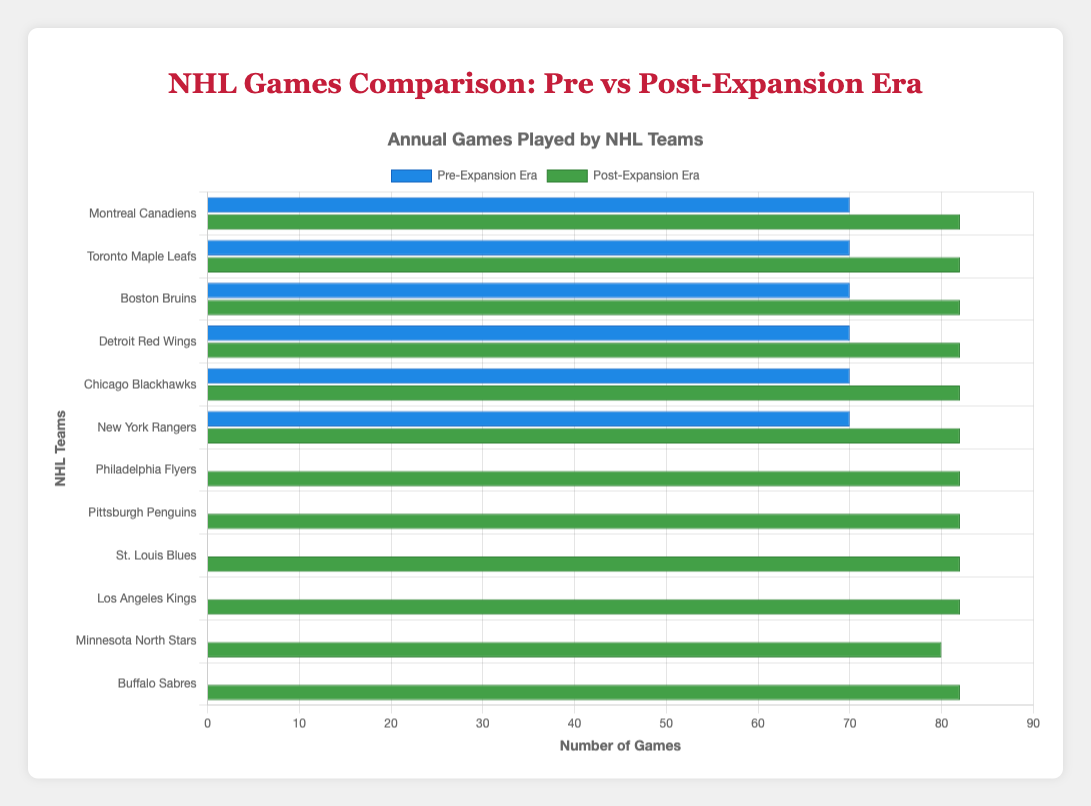Which team played the most games in the Post-Expansion Era? Compare the bar lengths in the Post-Expansion Era for all teams. The team with the longest bar played the most games. Montreal Canadiens, Toronto Maple Leafs, Boston Bruins, Detroit Red Wings, Chicago Blackhawks, New York Rangers, Philadelphia Flyers, Pittsburgh Penguins, St. Louis Blues, Los Angeles Kings, and Buffalo Sabres all have bars of the same length.
Answer: Montreal Canadiens, Toronto Maple Leafs, Boston Bruins, Detroit Red Wings, Chicago Blackhawks, New York Rangers, Philadelphia Flyers, Pittsburgh Penguins, St. Louis Blues, Los Angeles Kings, Buffalo Sabres How many more games did the Detroit Red Wings play in the Post-Expansion Era compared to the Pre-Expansion Era? Check the difference between the Post-Expansion Era bar length (82 games) and the Pre-Expansion Era bar length (70 games). The difference is 82 - 70 = 12 games.
Answer: 12 Which teams did not play any games in the Pre-Expansion Era? Identify the teams with a zero-length bar for the Pre-Expansion Era. These teams have no blue bars.
Answer: Philadelphia Flyers, Pittsburgh Penguins, St. Louis Blues, Los Angeles Kings, Minnesota North Stars, Buffalo Sabres Did any team play fewer games in the Post-Expansion Era than in the Pre-Expansion Era? Compare the two sets of bars for each team. Check if any team’s green bar is shorter than its blue bar. No green bar is shorter.
Answer: No What's the difference in games played between the Minnesota North Stars and Boston Bruins in the Post-Expansion Era? The Minnesota North Stars played 80 games, and the Boston Bruins played 82 games in the Post-Expansion Era. The difference is 82 - 80 = 2 games.
Answer: 2 Which teams have equal game counts in both eras? Compare the length of bars for each team in both eras. Bars of equal length will indicate the same game count. No team has equal bar lengths.
Answer: None What's the total number of games played by the Chicago Blackhawks in both eras combined? Sum the games played in the Pre-Expansion Era (70 games) and the Post-Expansion Era (82 games). The total is 70 + 82 = 152 games.
Answer: 152 How many teams have a green bar representing 82 games in the Post-Expansion Era? Count the number of teams having a Post-Expansion Era bar of length 82. There are multiple teams counted visually.
Answer: 10 